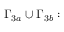<formula> <loc_0><loc_0><loc_500><loc_500>\Gamma _ { 3 a } \cup \Gamma _ { 3 b } \colon</formula> 